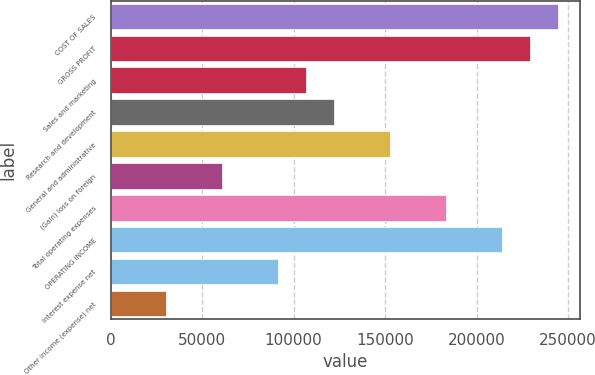Convert chart to OTSL. <chart><loc_0><loc_0><loc_500><loc_500><bar_chart><fcel>COST OF SALES<fcel>GROSS PROFIT<fcel>Sales and marketing<fcel>Research and development<fcel>General and administrative<fcel>(Gain) loss on foreign<fcel>Total operating expenses<fcel>OPERATING INCOME<fcel>Interest expense net<fcel>Other income (expense) net<nl><fcel>244476<fcel>229196<fcel>106959<fcel>122239<fcel>152798<fcel>61119.9<fcel>183357<fcel>213917<fcel>91679.3<fcel>30560.5<nl></chart> 